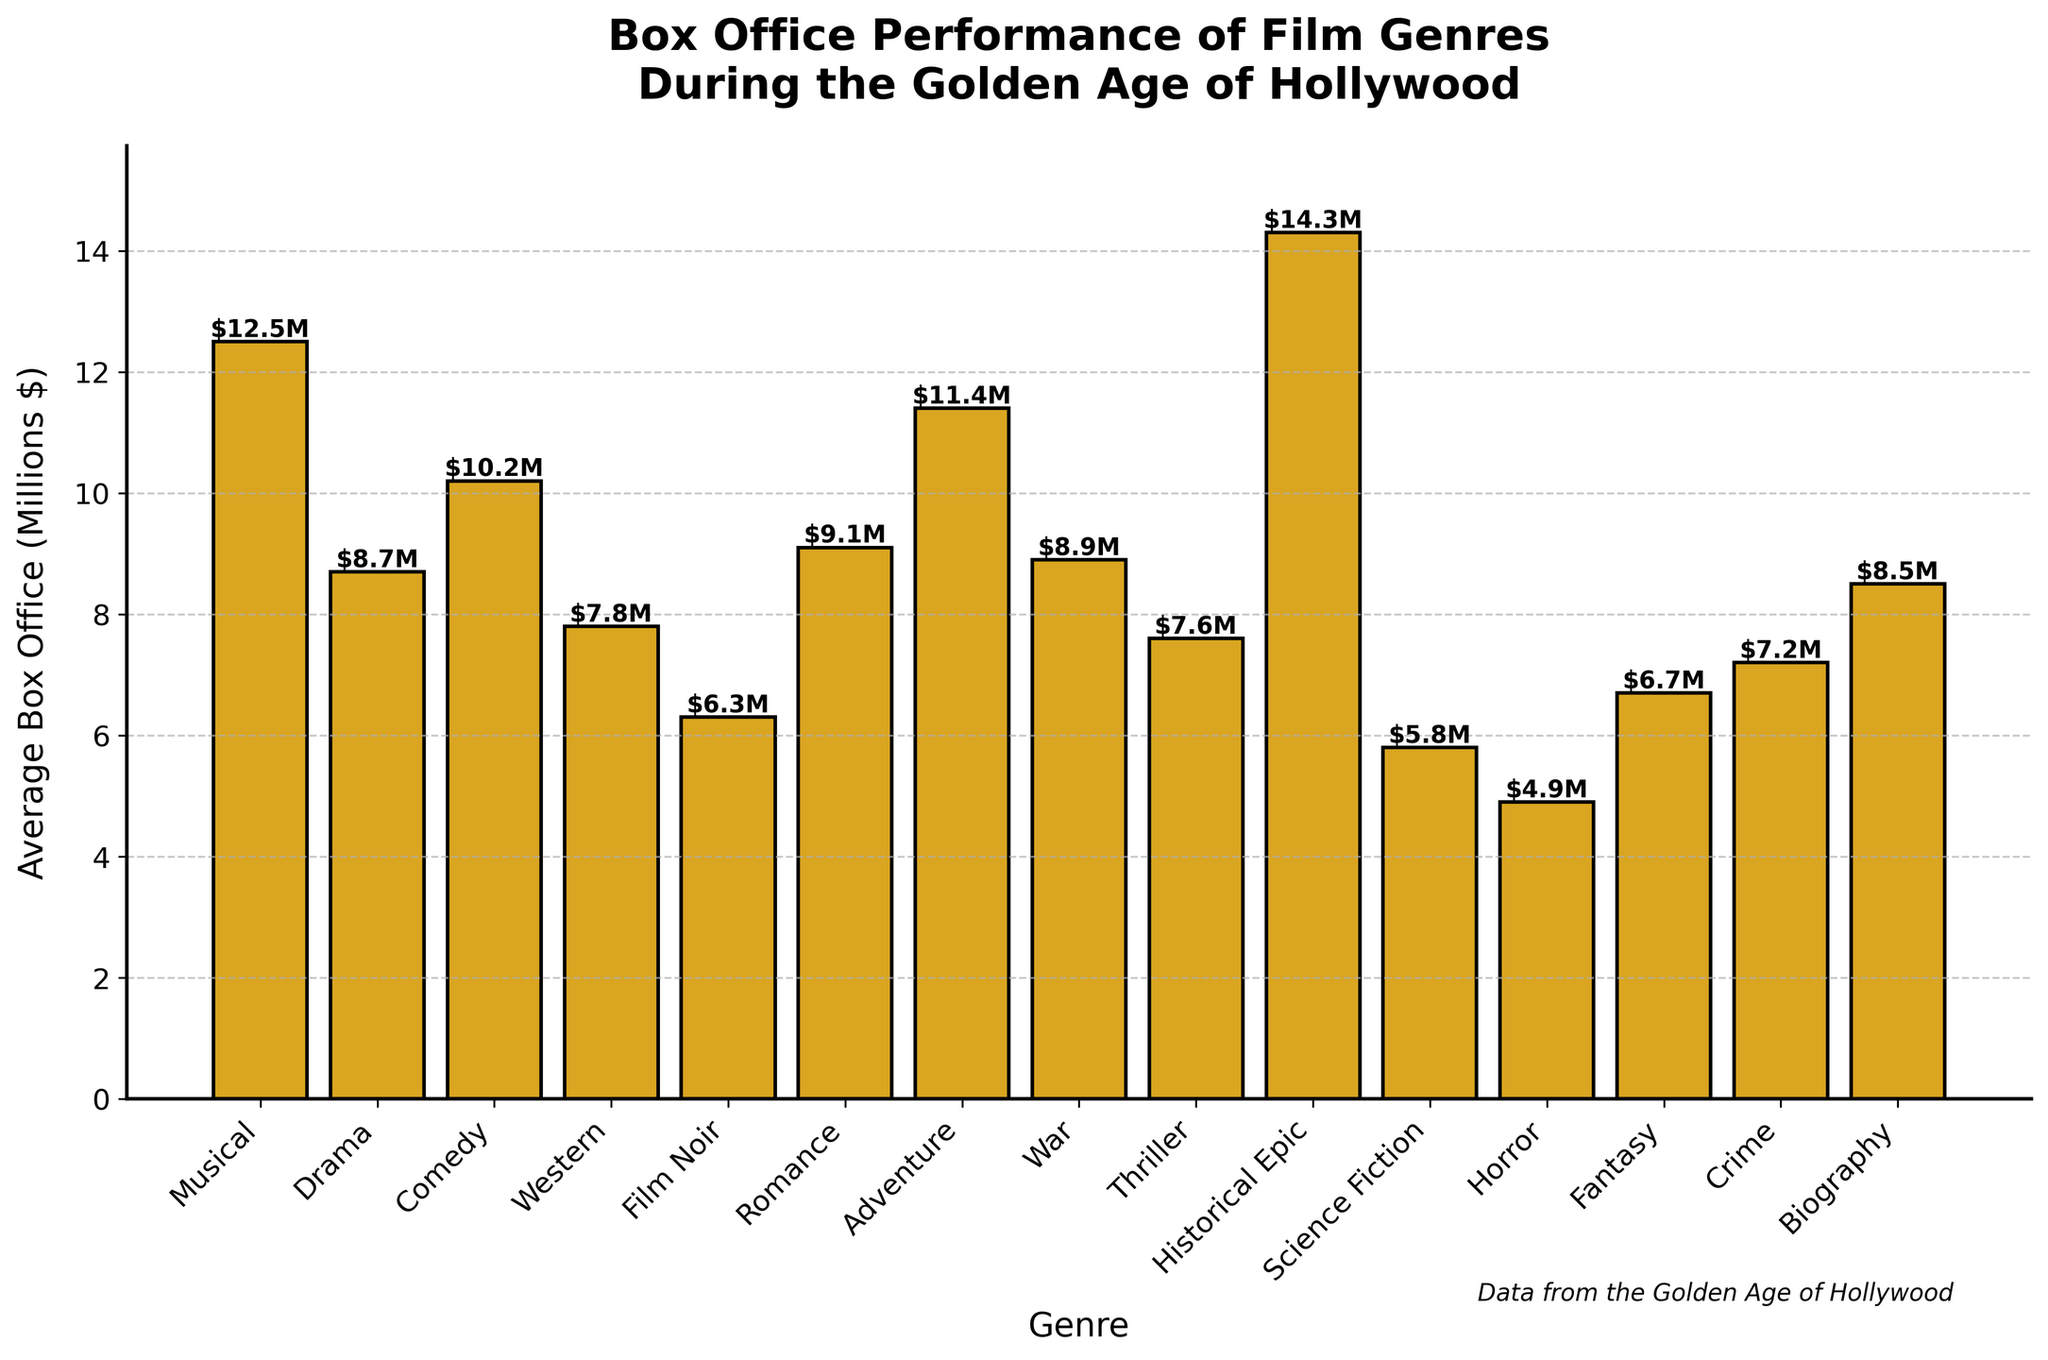What genre has the highest average box office performance? Look at the height of all bars and identify the tallest one. The tallest bar represents the genre with the highest average box office performance, which is Historical Epic.
Answer: Historical Epic How does the average box office of Science Fiction compare to that of Horror? Look at the bars for Science Fiction and Horror. Notice their heights, and compare them. Science Fiction has a height of 5.8 million dollars, while Horror has 4.9 million dollars.
Answer: Science Fiction is higher What is the combined average box office of Biography and Drama? Find the bars representing Biography and Drama. Add their values: 8.5 (Biography) + 8.7 (Drama) = 17.2.
Answer: 17.2 million dollars Which genre has a lower average box office: Film Noir or Fantasy? Look at the bars for Film Noir and Fantasy. Compare their heights. Film Noir is at 6.3 million dollars, while Fantasy is at 6.7 million dollars.
Answer: Film Noir Among the genres Comedy, Romance, and Adventure, which one has the highest average box office? Compare the heights of the bars for Comedy, Romance, and Adventure. The highest bar among these three is Adventure, at 11.4 million dollars.
Answer: Adventure By how much does the average box office of Historical Epic exceed the average box office of Western? Determine the height of the bars for Historical Epic and Western: 14.3 million dollars (Historical Epic) and 7.8 million dollars (Western). Subtract the latter from the former: 14.3 - 7.8 = 6.5.
Answer: 6.5 million dollars What is the average box office difference between the genres with the second and third highest average box office performances? Identify the bars with the second and third highest values, which are Musical (12.5 million dollars) and Adventure (11.4 million dollars), respectively. Subtract their values: 12.5 - 11.4 = 1.1.
Answer: 1.1 million dollars What is the average box office across all genres? Add all the values and divide by the number of genres. (12.5 + 8.7 + 10.2 + 7.8 + 6.3 + 9.1 + 11.4 + 8.9 + 7.6 + 14.3 + 5.8 + 4.9 + 6.7 + 7.2 + 8.5) / 15 = 8.58.
Answer: 8.58 million dollars Is the average box office for War films higher or lower than the average box office for Crime films? Look at the bars for War and Crime. War is 8.9 million dollars and Crime is 7.2 million dollars. Compare their heights.
Answer: Higher 